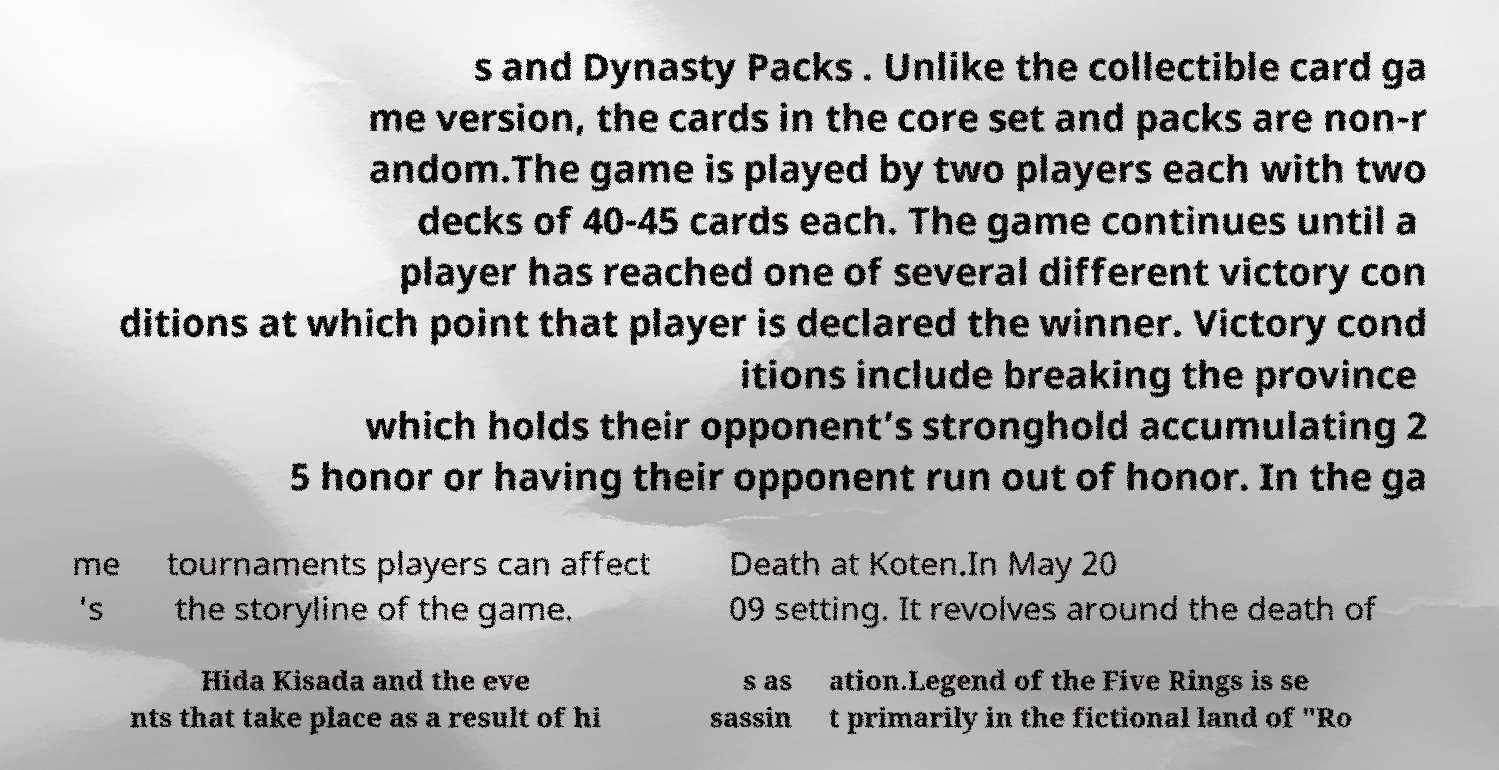Could you extract and type out the text from this image? s and Dynasty Packs . Unlike the collectible card ga me version, the cards in the core set and packs are non-r andom.The game is played by two players each with two decks of 40-45 cards each. The game continues until a player has reached one of several different victory con ditions at which point that player is declared the winner. Victory cond itions include breaking the province which holds their opponent’s stronghold accumulating 2 5 honor or having their opponent run out of honor. In the ga me 's tournaments players can affect the storyline of the game. Death at Koten.In May 20 09 setting. It revolves around the death of Hida Kisada and the eve nts that take place as a result of hi s as sassin ation.Legend of the Five Rings is se t primarily in the fictional land of "Ro 